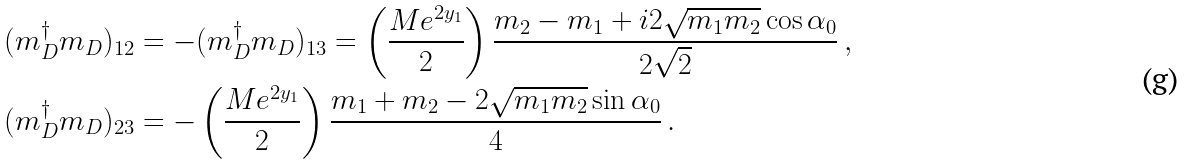<formula> <loc_0><loc_0><loc_500><loc_500>( m _ { D } ^ { \dag } m _ { D } ) _ { 1 2 } & = - ( m _ { D } ^ { \dag } m _ { D } ) _ { 1 3 } = \left ( \frac { M e ^ { 2 y _ { 1 } } } { 2 } \right ) \frac { m _ { 2 } - m _ { 1 } + i 2 { \sqrt { m _ { 1 } m _ { 2 } } } \cos \alpha _ { 0 } } { 2 \sqrt { 2 } } \, , \\ ( m _ { D } ^ { \dag } m _ { D } ) _ { 2 3 } & = - \left ( \frac { M e ^ { 2 y _ { 1 } } } { 2 } \right ) \frac { m _ { 1 } + m _ { 2 } - 2 \sqrt { m _ { 1 } m _ { 2 } } \sin \alpha _ { 0 } } { 4 } \, .</formula> 